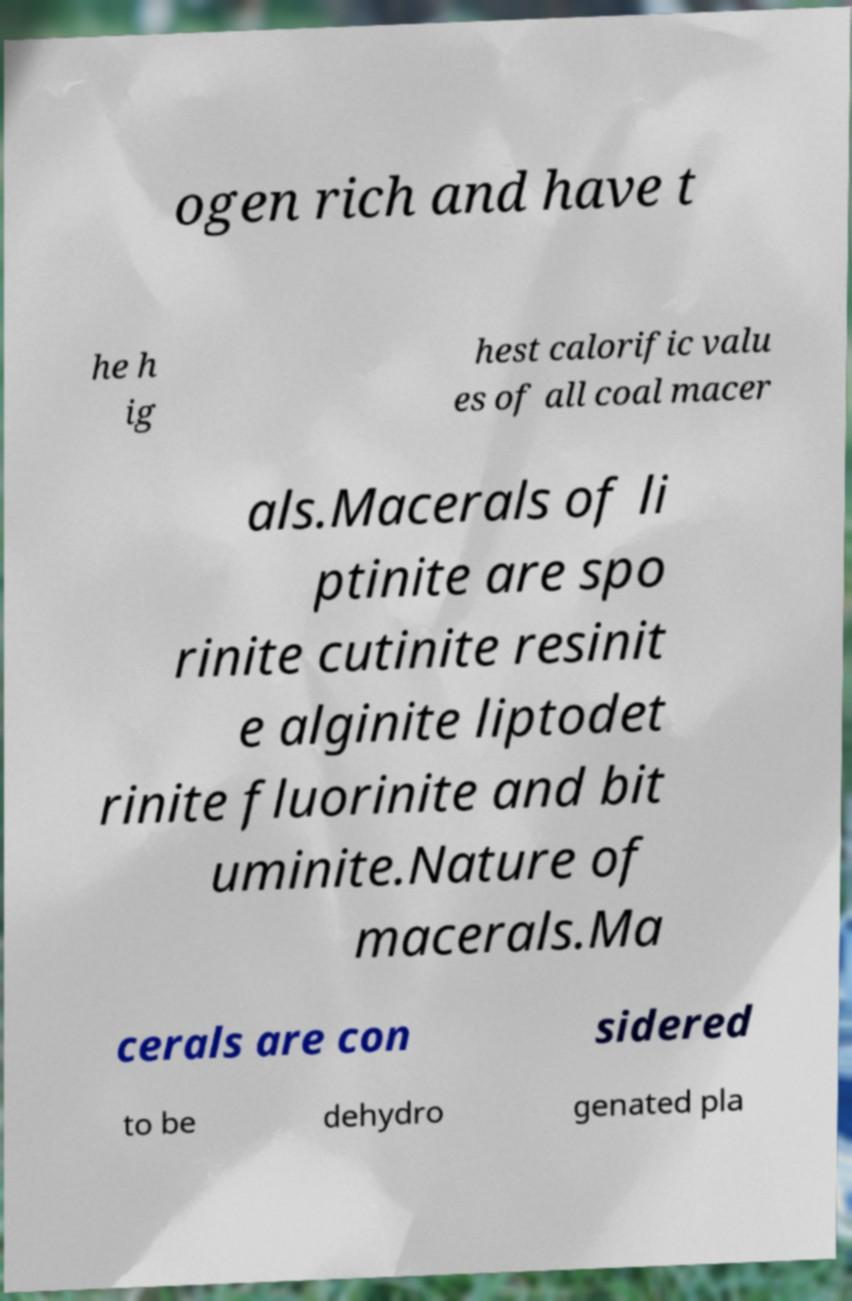Could you assist in decoding the text presented in this image and type it out clearly? ogen rich and have t he h ig hest calorific valu es of all coal macer als.Macerals of li ptinite are spo rinite cutinite resinit e alginite liptodet rinite fluorinite and bit uminite.Nature of macerals.Ma cerals are con sidered to be dehydro genated pla 